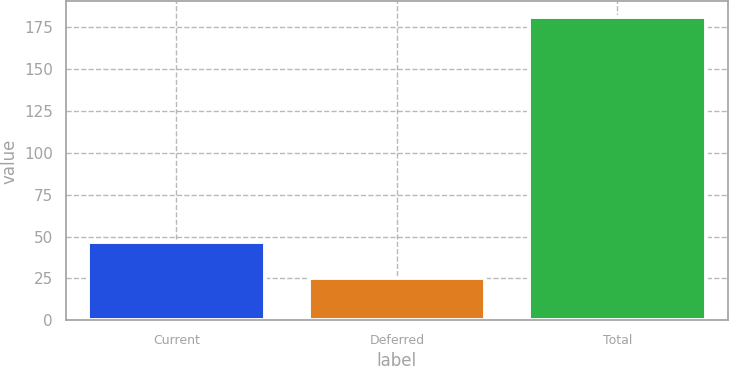Convert chart to OTSL. <chart><loc_0><loc_0><loc_500><loc_500><bar_chart><fcel>Current<fcel>Deferred<fcel>Total<nl><fcel>46.9<fcel>25.2<fcel>181.2<nl></chart> 